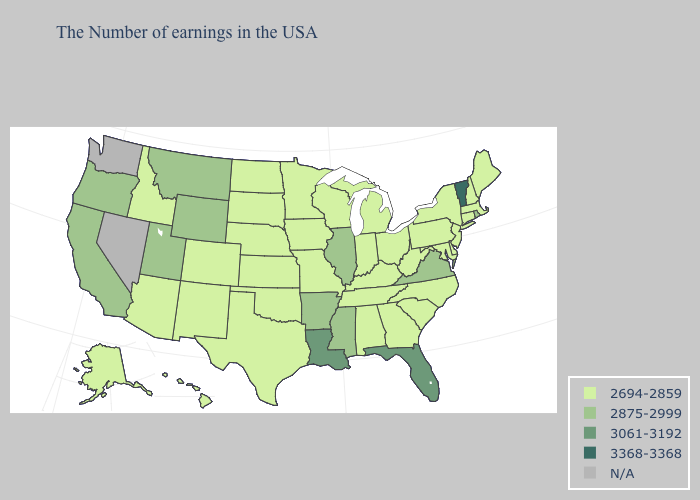Name the states that have a value in the range 3368-3368?
Be succinct. Vermont. Name the states that have a value in the range 2875-2999?
Give a very brief answer. Rhode Island, Virginia, Illinois, Mississippi, Arkansas, Wyoming, Utah, Montana, California, Oregon. Does the first symbol in the legend represent the smallest category?
Be succinct. Yes. What is the lowest value in the MidWest?
Write a very short answer. 2694-2859. How many symbols are there in the legend?
Keep it brief. 5. Does Utah have the lowest value in the West?
Quick response, please. No. What is the highest value in the USA?
Be succinct. 3368-3368. Among the states that border New Mexico , does Utah have the lowest value?
Be succinct. No. Is the legend a continuous bar?
Concise answer only. No. What is the value of Alaska?
Concise answer only. 2694-2859. Name the states that have a value in the range 2694-2859?
Answer briefly. Maine, Massachusetts, New Hampshire, Connecticut, New York, New Jersey, Delaware, Maryland, Pennsylvania, North Carolina, South Carolina, West Virginia, Ohio, Georgia, Michigan, Kentucky, Indiana, Alabama, Tennessee, Wisconsin, Missouri, Minnesota, Iowa, Kansas, Nebraska, Oklahoma, Texas, South Dakota, North Dakota, Colorado, New Mexico, Arizona, Idaho, Alaska, Hawaii. What is the lowest value in the USA?
Short answer required. 2694-2859. Does Wyoming have the highest value in the USA?
Keep it brief. No. What is the lowest value in states that border Maine?
Be succinct. 2694-2859. Does Rhode Island have the highest value in the USA?
Be succinct. No. 